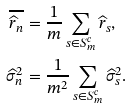Convert formula to latex. <formula><loc_0><loc_0><loc_500><loc_500>\overline { \widehat { r } _ { n } } & = \frac { 1 } { m } \sum _ { s \in S _ { m } ^ { c } } { \widehat { r } _ { s } } , \\ \widehat { \sigma } ^ { 2 } _ { n } & = \frac { 1 } { m ^ { 2 } } \sum _ { s \in S _ { m } ^ { c } } { \widehat { \sigma } ^ { 2 } _ { s } } .</formula> 